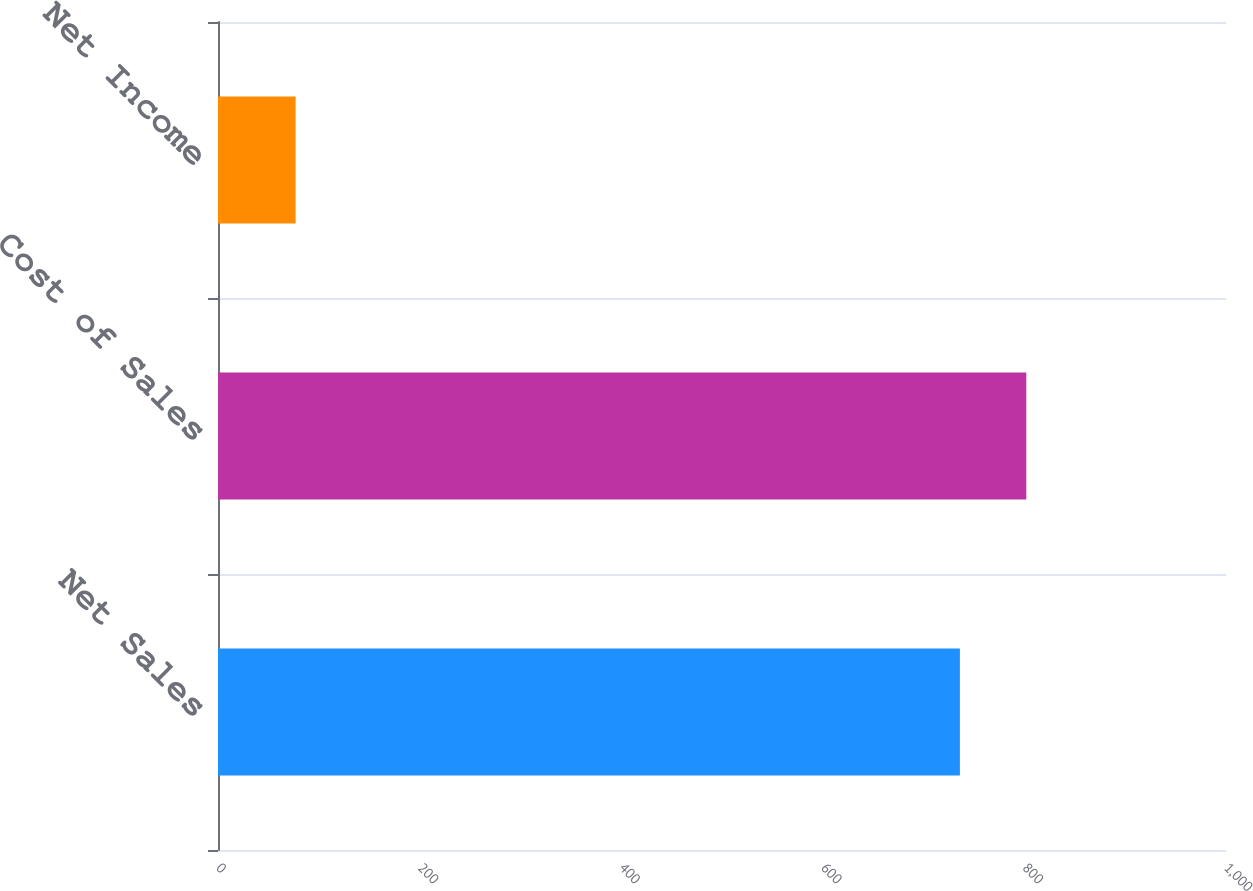Convert chart to OTSL. <chart><loc_0><loc_0><loc_500><loc_500><bar_chart><fcel>Net Sales<fcel>Cost of Sales<fcel>Net Income<nl><fcel>736<fcel>801.9<fcel>77<nl></chart> 